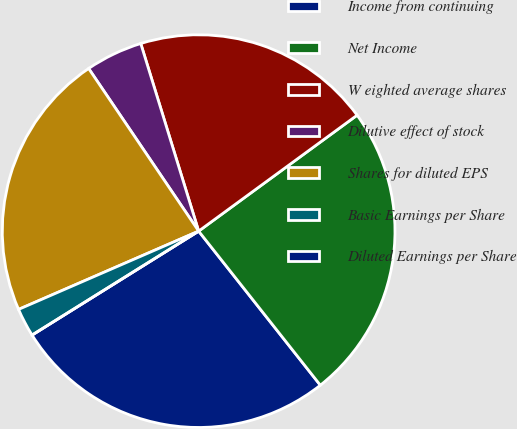Convert chart. <chart><loc_0><loc_0><loc_500><loc_500><pie_chart><fcel>Income from continuing<fcel>Net Income<fcel>W eighted average shares<fcel>Dilutive effect of stock<fcel>Shares for diluted EPS<fcel>Basic Earnings per Share<fcel>Diluted Earnings per Share<nl><fcel>26.76%<fcel>24.41%<fcel>19.71%<fcel>4.7%<fcel>22.06%<fcel>2.35%<fcel>0.0%<nl></chart> 